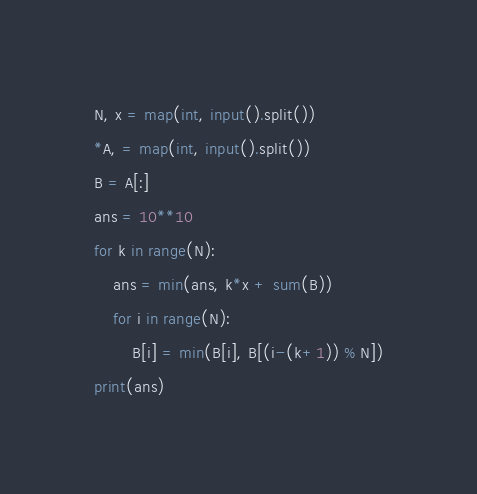<code> <loc_0><loc_0><loc_500><loc_500><_Python_>N, x = map(int, input().split())
*A, = map(int, input().split())
B = A[:]
ans = 10**10
for k in range(N):
    ans = min(ans, k*x + sum(B))
    for i in range(N):
        B[i] = min(B[i], B[(i-(k+1)) % N])
print(ans)</code> 